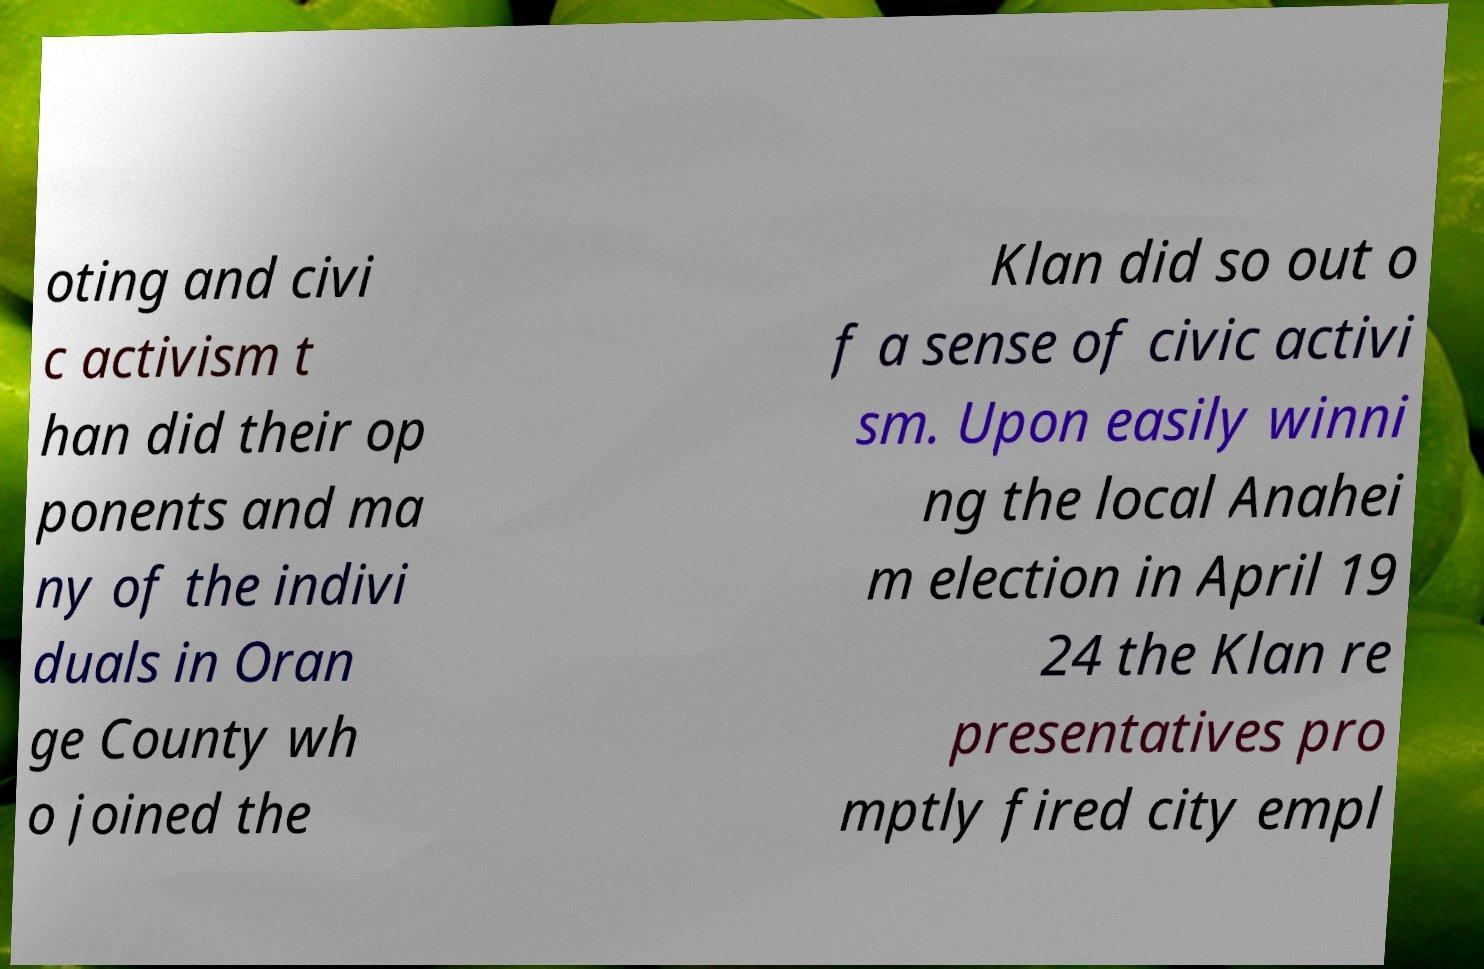Could you assist in decoding the text presented in this image and type it out clearly? oting and civi c activism t han did their op ponents and ma ny of the indivi duals in Oran ge County wh o joined the Klan did so out o f a sense of civic activi sm. Upon easily winni ng the local Anahei m election in April 19 24 the Klan re presentatives pro mptly fired city empl 